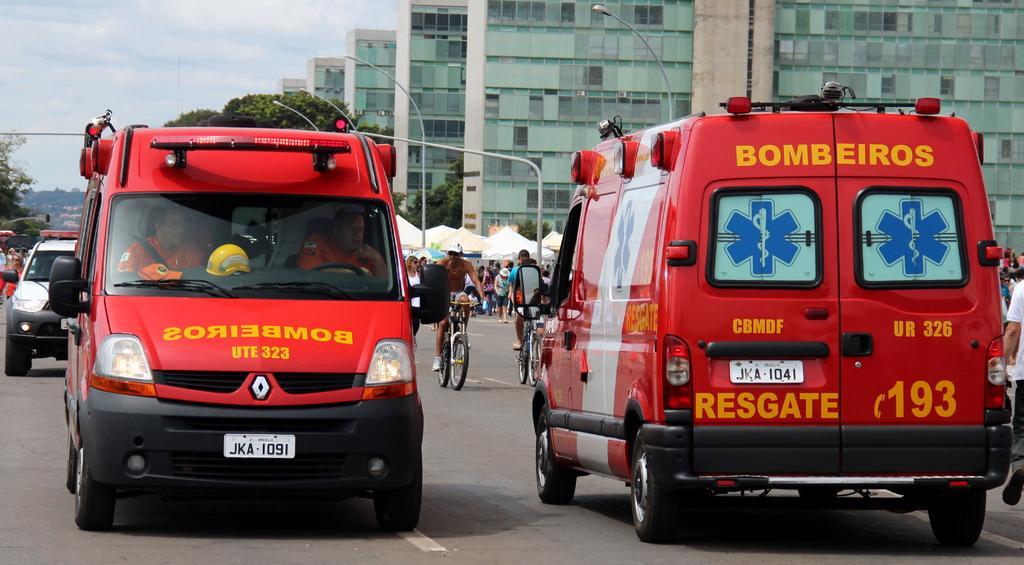In one or two sentences, can you explain what this image depicts? In this picture I can see few vehicles in the middle, in the background two persons are riding their bicycles, there are few people, buildings, street lamps and trees. At the top I can see the sky. 